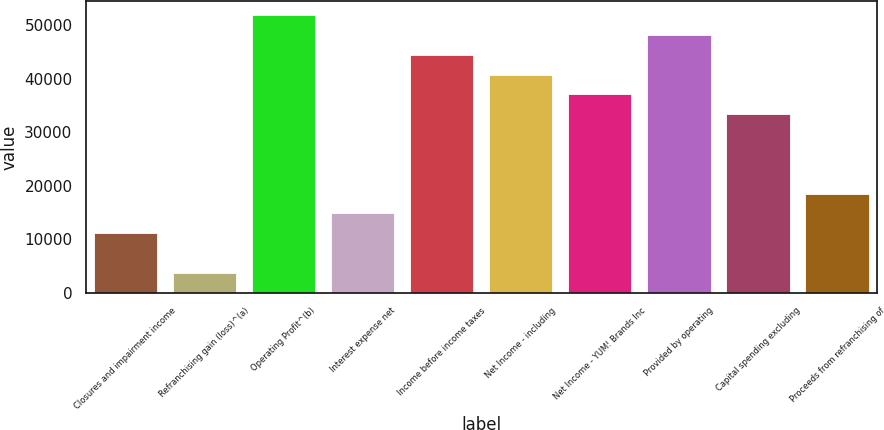<chart> <loc_0><loc_0><loc_500><loc_500><bar_chart><fcel>Closures and impairment income<fcel>Refranchising gain (loss)^(a)<fcel>Operating Profit^(b)<fcel>Interest expense net<fcel>Income before income taxes<fcel>Net Income - including<fcel>Net Income - YUM! Brands Inc<fcel>Provided by operating<fcel>Capital spending excluding<fcel>Proceeds from refranchising of<nl><fcel>11124.6<fcel>3708.72<fcel>51911.7<fcel>14832.5<fcel>44495.8<fcel>40787.9<fcel>37080<fcel>48203.8<fcel>33372.1<fcel>18540.4<nl></chart> 